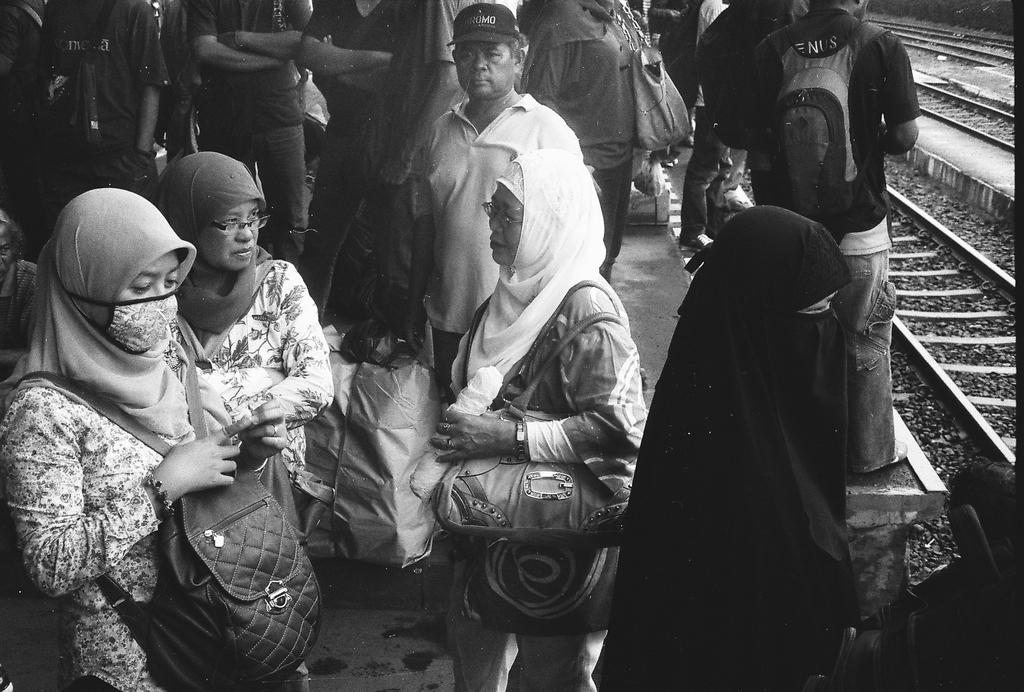What is the color scheme of the image? The image is black and white. What are the majority of the persons in the image doing? Most of the persons in the image are standing. What are the persons carrying in the image? The persons are carrying bags, which are considered luggage. What can be seen in the background of the image? There is a train track visible in the image. What type of shelf can be seen in the image? There is no shelf present in the image. What experience do the persons in the image share? The image does not provide information about the shared experiences of the persons. 